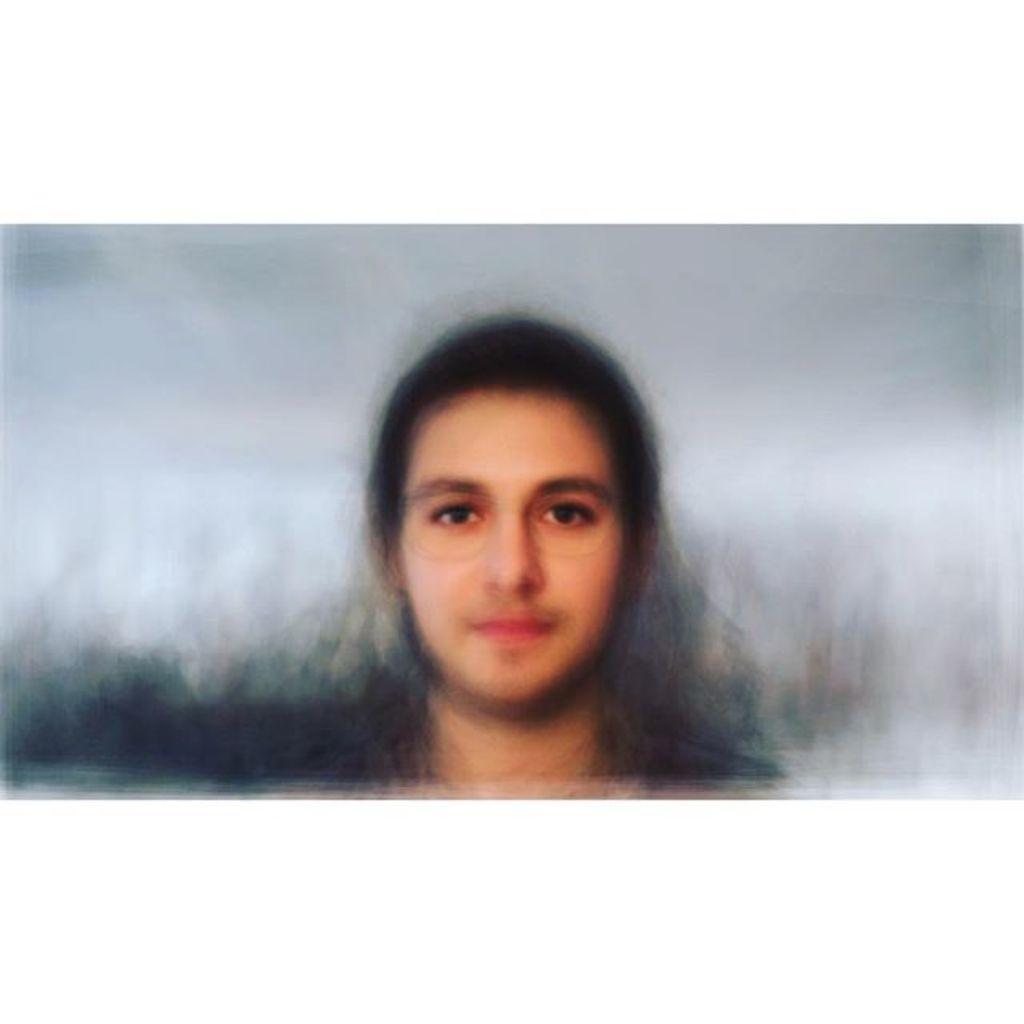How would you summarize this image in a sentence or two? This image consists of a person. It looks like an edited image. The background is blurred. 